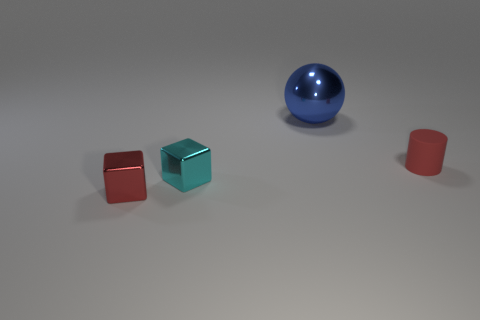Add 3 tiny red cylinders. How many objects exist? 7 Subtract all cylinders. How many objects are left? 3 Add 1 large gray cylinders. How many large gray cylinders exist? 1 Subtract 0 blue cylinders. How many objects are left? 4 Subtract all cyan cubes. Subtract all large blue spheres. How many objects are left? 2 Add 2 small cyan metallic objects. How many small cyan metallic objects are left? 3 